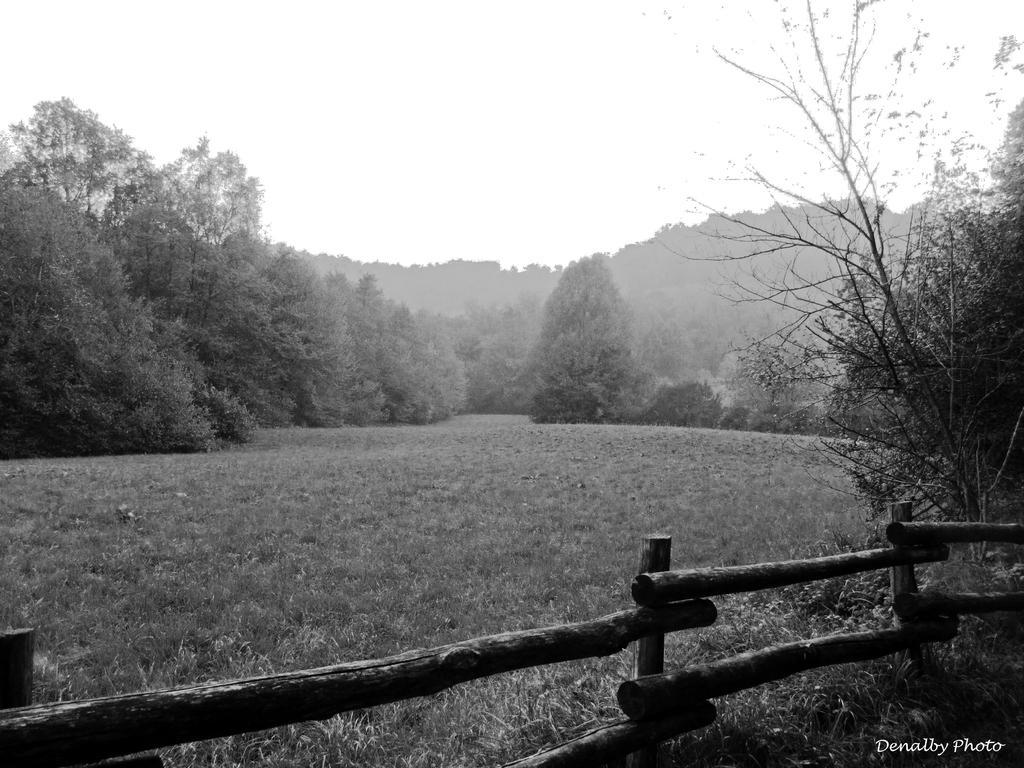Describe this image in one or two sentences. In this picture we can describe about black and white view of the photograph. In the front we can see a grass lawn and bamboo fencing railing. Behind we can see some some trees. 